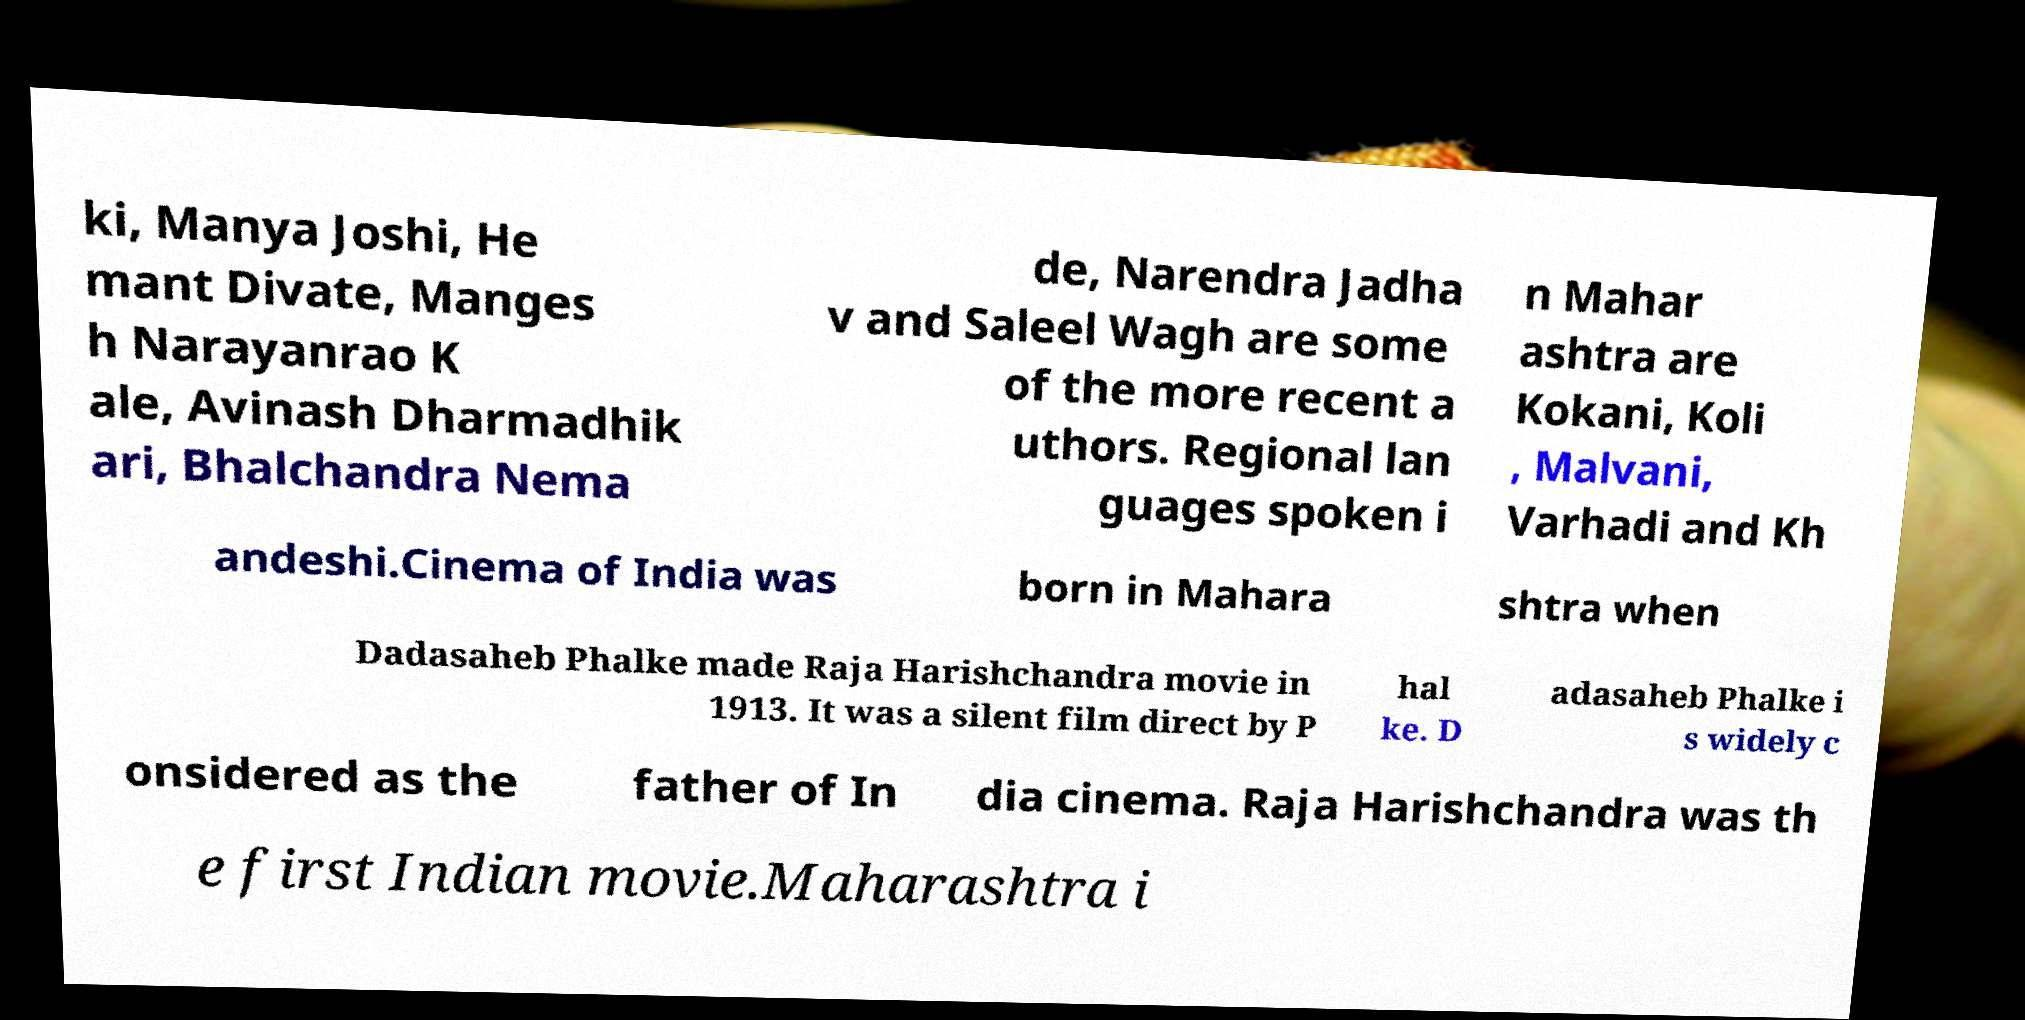Could you extract and type out the text from this image? ki, Manya Joshi, He mant Divate, Manges h Narayanrao K ale, Avinash Dharmadhik ari, Bhalchandra Nema de, Narendra Jadha v and Saleel Wagh are some of the more recent a uthors. Regional lan guages spoken i n Mahar ashtra are Kokani, Koli , Malvani, Varhadi and Kh andeshi.Cinema of India was born in Mahara shtra when Dadasaheb Phalke made Raja Harishchandra movie in 1913. It was a silent film direct by P hal ke. D adasaheb Phalke i s widely c onsidered as the father of In dia cinema. Raja Harishchandra was th e first Indian movie.Maharashtra i 